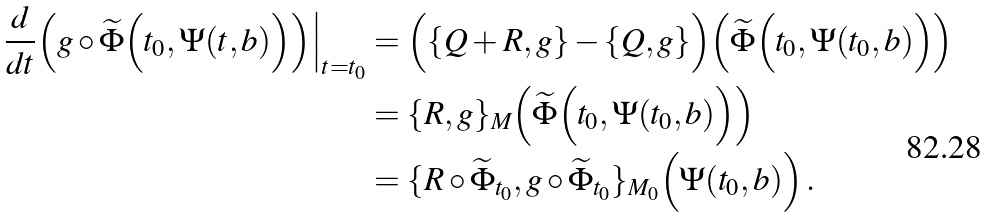Convert formula to latex. <formula><loc_0><loc_0><loc_500><loc_500>\frac { d } { d t } \Big ( g \circ { \widetilde { \Phi } } \Big ( t _ { 0 } , \Psi ( t , b ) \Big ) \Big ) \Big | _ { t = t _ { 0 } } & = \Big ( \{ Q + R , g \} - \{ Q , g \} \Big ) \Big ( { \widetilde { \Phi } } \Big ( t _ { 0 } , \Psi ( t _ { 0 } , b ) \Big ) \Big ) \\ & = \{ R , g \} _ { M } \Big ( { \widetilde { \Phi } } \Big ( t _ { 0 } , \Psi ( t _ { 0 } , b ) \Big ) \Big ) \\ & = \{ R \circ { \widetilde { \Phi } } _ { t _ { 0 } } , g \circ { \widetilde { \Phi } } _ { t _ { 0 } } \} _ { M _ { 0 } } \Big ( \Psi ( t _ { 0 } , b ) \Big ) \, .</formula> 